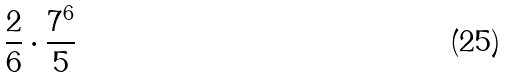<formula> <loc_0><loc_0><loc_500><loc_500>\frac { 2 } { 6 } \cdot \frac { 7 ^ { 6 } } { 5 }</formula> 